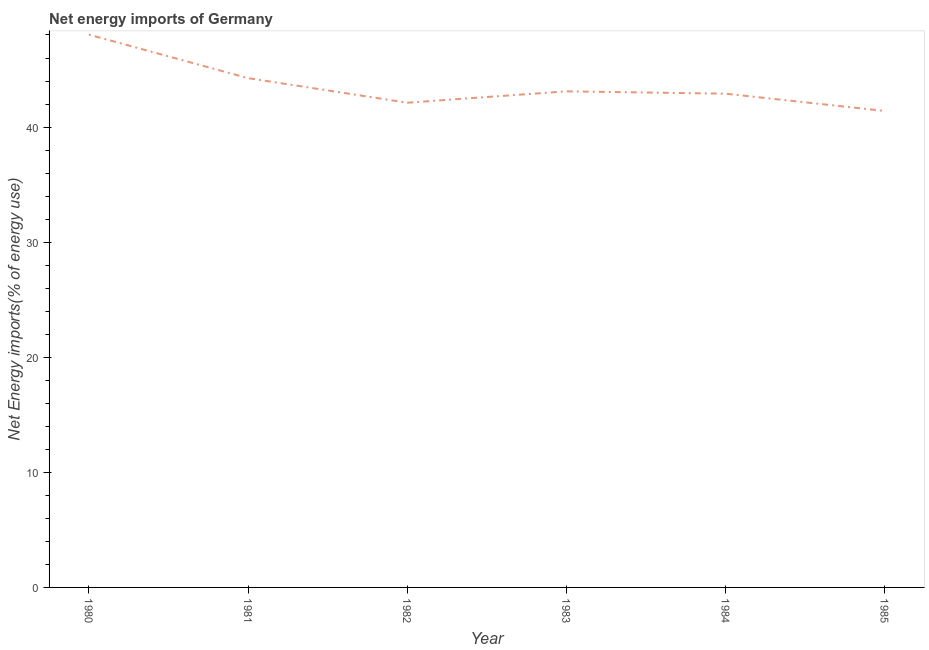What is the energy imports in 1980?
Your answer should be very brief. 48.03. Across all years, what is the maximum energy imports?
Make the answer very short. 48.03. Across all years, what is the minimum energy imports?
Give a very brief answer. 41.4. What is the sum of the energy imports?
Your answer should be compact. 261.8. What is the difference between the energy imports in 1982 and 1984?
Your answer should be very brief. -0.78. What is the average energy imports per year?
Give a very brief answer. 43.63. What is the median energy imports?
Your response must be concise. 43. What is the ratio of the energy imports in 1982 to that in 1983?
Make the answer very short. 0.98. Is the energy imports in 1980 less than that in 1982?
Your answer should be very brief. No. Is the difference between the energy imports in 1981 and 1982 greater than the difference between any two years?
Your answer should be very brief. No. What is the difference between the highest and the second highest energy imports?
Your response must be concise. 3.78. Is the sum of the energy imports in 1981 and 1984 greater than the maximum energy imports across all years?
Provide a succinct answer. Yes. What is the difference between the highest and the lowest energy imports?
Offer a very short reply. 6.63. In how many years, is the energy imports greater than the average energy imports taken over all years?
Ensure brevity in your answer.  2. Does the energy imports monotonically increase over the years?
Keep it short and to the point. No. How many lines are there?
Your answer should be compact. 1. What is the difference between two consecutive major ticks on the Y-axis?
Make the answer very short. 10. What is the title of the graph?
Your answer should be very brief. Net energy imports of Germany. What is the label or title of the X-axis?
Provide a short and direct response. Year. What is the label or title of the Y-axis?
Offer a terse response. Net Energy imports(% of energy use). What is the Net Energy imports(% of energy use) in 1980?
Give a very brief answer. 48.03. What is the Net Energy imports(% of energy use) of 1981?
Provide a short and direct response. 44.25. What is the Net Energy imports(% of energy use) of 1982?
Ensure brevity in your answer.  42.12. What is the Net Energy imports(% of energy use) in 1983?
Provide a succinct answer. 43.1. What is the Net Energy imports(% of energy use) in 1984?
Give a very brief answer. 42.9. What is the Net Energy imports(% of energy use) in 1985?
Your answer should be very brief. 41.4. What is the difference between the Net Energy imports(% of energy use) in 1980 and 1981?
Your response must be concise. 3.78. What is the difference between the Net Energy imports(% of energy use) in 1980 and 1982?
Your answer should be very brief. 5.91. What is the difference between the Net Energy imports(% of energy use) in 1980 and 1983?
Your answer should be very brief. 4.93. What is the difference between the Net Energy imports(% of energy use) in 1980 and 1984?
Offer a terse response. 5.13. What is the difference between the Net Energy imports(% of energy use) in 1980 and 1985?
Make the answer very short. 6.63. What is the difference between the Net Energy imports(% of energy use) in 1981 and 1982?
Ensure brevity in your answer.  2.13. What is the difference between the Net Energy imports(% of energy use) in 1981 and 1983?
Offer a terse response. 1.15. What is the difference between the Net Energy imports(% of energy use) in 1981 and 1984?
Ensure brevity in your answer.  1.35. What is the difference between the Net Energy imports(% of energy use) in 1981 and 1985?
Your answer should be compact. 2.85. What is the difference between the Net Energy imports(% of energy use) in 1982 and 1983?
Your answer should be compact. -0.99. What is the difference between the Net Energy imports(% of energy use) in 1982 and 1984?
Provide a succinct answer. -0.78. What is the difference between the Net Energy imports(% of energy use) in 1982 and 1985?
Your answer should be compact. 0.72. What is the difference between the Net Energy imports(% of energy use) in 1983 and 1984?
Ensure brevity in your answer.  0.2. What is the difference between the Net Energy imports(% of energy use) in 1983 and 1985?
Offer a very short reply. 1.7. What is the difference between the Net Energy imports(% of energy use) in 1984 and 1985?
Offer a very short reply. 1.5. What is the ratio of the Net Energy imports(% of energy use) in 1980 to that in 1981?
Keep it short and to the point. 1.08. What is the ratio of the Net Energy imports(% of energy use) in 1980 to that in 1982?
Provide a short and direct response. 1.14. What is the ratio of the Net Energy imports(% of energy use) in 1980 to that in 1983?
Provide a succinct answer. 1.11. What is the ratio of the Net Energy imports(% of energy use) in 1980 to that in 1984?
Ensure brevity in your answer.  1.12. What is the ratio of the Net Energy imports(% of energy use) in 1980 to that in 1985?
Make the answer very short. 1.16. What is the ratio of the Net Energy imports(% of energy use) in 1981 to that in 1982?
Provide a succinct answer. 1.05. What is the ratio of the Net Energy imports(% of energy use) in 1981 to that in 1983?
Provide a short and direct response. 1.03. What is the ratio of the Net Energy imports(% of energy use) in 1981 to that in 1984?
Your answer should be very brief. 1.03. What is the ratio of the Net Energy imports(% of energy use) in 1981 to that in 1985?
Your response must be concise. 1.07. What is the ratio of the Net Energy imports(% of energy use) in 1982 to that in 1984?
Your answer should be very brief. 0.98. What is the ratio of the Net Energy imports(% of energy use) in 1983 to that in 1985?
Ensure brevity in your answer.  1.04. What is the ratio of the Net Energy imports(% of energy use) in 1984 to that in 1985?
Keep it short and to the point. 1.04. 